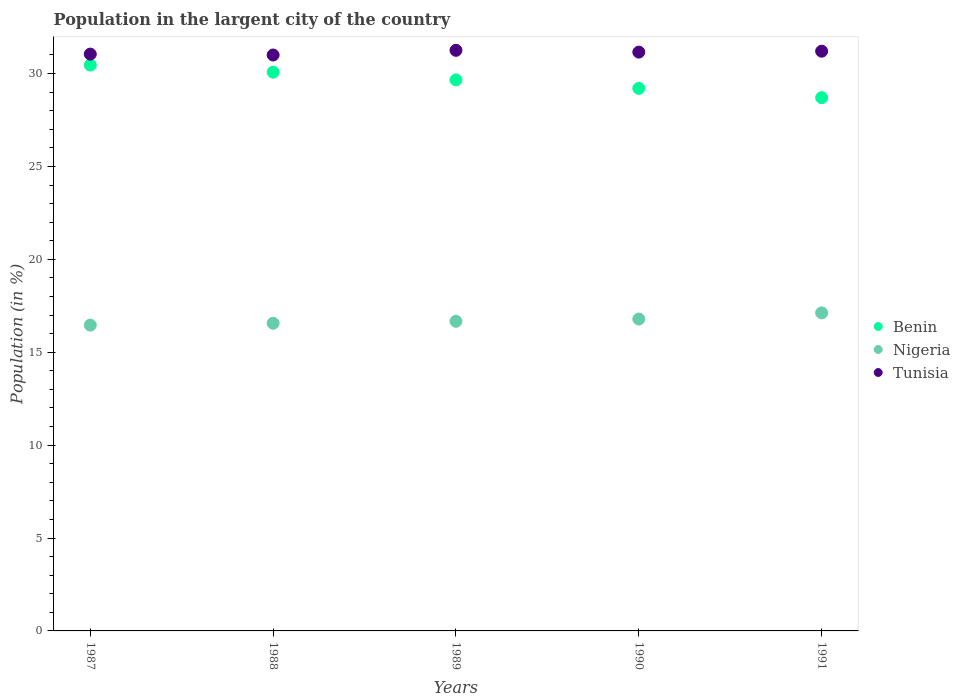How many different coloured dotlines are there?
Ensure brevity in your answer.  3. What is the percentage of population in the largent city in Tunisia in 1991?
Your answer should be very brief. 31.2. Across all years, what is the maximum percentage of population in the largent city in Benin?
Keep it short and to the point. 30.46. Across all years, what is the minimum percentage of population in the largent city in Tunisia?
Keep it short and to the point. 31. In which year was the percentage of population in the largent city in Tunisia minimum?
Your answer should be compact. 1988. What is the total percentage of population in the largent city in Tunisia in the graph?
Keep it short and to the point. 155.66. What is the difference between the percentage of population in the largent city in Nigeria in 1988 and that in 1989?
Provide a succinct answer. -0.11. What is the difference between the percentage of population in the largent city in Tunisia in 1991 and the percentage of population in the largent city in Benin in 1989?
Your response must be concise. 1.54. What is the average percentage of population in the largent city in Tunisia per year?
Your answer should be very brief. 31.13. In the year 1987, what is the difference between the percentage of population in the largent city in Nigeria and percentage of population in the largent city in Tunisia?
Give a very brief answer. -14.59. What is the ratio of the percentage of population in the largent city in Benin in 1989 to that in 1990?
Ensure brevity in your answer.  1.02. Is the percentage of population in the largent city in Tunisia in 1987 less than that in 1990?
Your answer should be compact. Yes. Is the difference between the percentage of population in the largent city in Nigeria in 1988 and 1991 greater than the difference between the percentage of population in the largent city in Tunisia in 1988 and 1991?
Your response must be concise. No. What is the difference between the highest and the second highest percentage of population in the largent city in Tunisia?
Your response must be concise. 0.05. What is the difference between the highest and the lowest percentage of population in the largent city in Nigeria?
Your answer should be compact. 0.66. In how many years, is the percentage of population in the largent city in Benin greater than the average percentage of population in the largent city in Benin taken over all years?
Your answer should be compact. 3. Is the sum of the percentage of population in the largent city in Nigeria in 1988 and 1990 greater than the maximum percentage of population in the largent city in Benin across all years?
Keep it short and to the point. Yes. Is it the case that in every year, the sum of the percentage of population in the largent city in Tunisia and percentage of population in the largent city in Nigeria  is greater than the percentage of population in the largent city in Benin?
Give a very brief answer. Yes. Is the percentage of population in the largent city in Benin strictly greater than the percentage of population in the largent city in Tunisia over the years?
Your response must be concise. No. How many years are there in the graph?
Make the answer very short. 5. What is the difference between two consecutive major ticks on the Y-axis?
Your response must be concise. 5. Does the graph contain any zero values?
Provide a short and direct response. No. Does the graph contain grids?
Your answer should be compact. No. Where does the legend appear in the graph?
Offer a very short reply. Center right. What is the title of the graph?
Your answer should be very brief. Population in the largent city of the country. Does "Israel" appear as one of the legend labels in the graph?
Keep it short and to the point. No. What is the label or title of the X-axis?
Make the answer very short. Years. What is the label or title of the Y-axis?
Offer a very short reply. Population (in %). What is the Population (in %) in Benin in 1987?
Offer a terse response. 30.46. What is the Population (in %) of Nigeria in 1987?
Offer a terse response. 16.46. What is the Population (in %) in Tunisia in 1987?
Your answer should be very brief. 31.05. What is the Population (in %) in Benin in 1988?
Offer a very short reply. 30.08. What is the Population (in %) in Nigeria in 1988?
Offer a very short reply. 16.56. What is the Population (in %) of Tunisia in 1988?
Ensure brevity in your answer.  31. What is the Population (in %) in Benin in 1989?
Provide a succinct answer. 29.66. What is the Population (in %) of Nigeria in 1989?
Offer a terse response. 16.67. What is the Population (in %) of Tunisia in 1989?
Make the answer very short. 31.25. What is the Population (in %) in Benin in 1990?
Your answer should be compact. 29.2. What is the Population (in %) of Nigeria in 1990?
Offer a very short reply. 16.79. What is the Population (in %) in Tunisia in 1990?
Offer a terse response. 31.15. What is the Population (in %) in Benin in 1991?
Ensure brevity in your answer.  28.7. What is the Population (in %) of Nigeria in 1991?
Your response must be concise. 17.12. What is the Population (in %) of Tunisia in 1991?
Ensure brevity in your answer.  31.2. Across all years, what is the maximum Population (in %) of Benin?
Offer a terse response. 30.46. Across all years, what is the maximum Population (in %) of Nigeria?
Offer a very short reply. 17.12. Across all years, what is the maximum Population (in %) of Tunisia?
Your response must be concise. 31.25. Across all years, what is the minimum Population (in %) in Benin?
Offer a terse response. 28.7. Across all years, what is the minimum Population (in %) of Nigeria?
Offer a very short reply. 16.46. Across all years, what is the minimum Population (in %) in Tunisia?
Ensure brevity in your answer.  31. What is the total Population (in %) of Benin in the graph?
Offer a terse response. 148.1. What is the total Population (in %) in Nigeria in the graph?
Make the answer very short. 83.59. What is the total Population (in %) in Tunisia in the graph?
Your answer should be very brief. 155.66. What is the difference between the Population (in %) in Benin in 1987 and that in 1988?
Offer a very short reply. 0.38. What is the difference between the Population (in %) in Nigeria in 1987 and that in 1988?
Offer a terse response. -0.1. What is the difference between the Population (in %) of Tunisia in 1987 and that in 1988?
Your answer should be compact. 0.05. What is the difference between the Population (in %) in Benin in 1987 and that in 1989?
Your answer should be very brief. 0.8. What is the difference between the Population (in %) in Nigeria in 1987 and that in 1989?
Provide a short and direct response. -0.21. What is the difference between the Population (in %) of Tunisia in 1987 and that in 1989?
Provide a succinct answer. -0.2. What is the difference between the Population (in %) of Benin in 1987 and that in 1990?
Provide a succinct answer. 1.26. What is the difference between the Population (in %) in Nigeria in 1987 and that in 1990?
Offer a terse response. -0.33. What is the difference between the Population (in %) in Tunisia in 1987 and that in 1990?
Your response must be concise. -0.11. What is the difference between the Population (in %) of Benin in 1987 and that in 1991?
Your answer should be compact. 1.76. What is the difference between the Population (in %) in Nigeria in 1987 and that in 1991?
Offer a terse response. -0.66. What is the difference between the Population (in %) of Tunisia in 1987 and that in 1991?
Offer a very short reply. -0.16. What is the difference between the Population (in %) of Benin in 1988 and that in 1989?
Offer a very short reply. 0.42. What is the difference between the Population (in %) in Nigeria in 1988 and that in 1989?
Provide a short and direct response. -0.11. What is the difference between the Population (in %) in Tunisia in 1988 and that in 1989?
Your answer should be compact. -0.25. What is the difference between the Population (in %) in Benin in 1988 and that in 1990?
Offer a very short reply. 0.87. What is the difference between the Population (in %) in Nigeria in 1988 and that in 1990?
Make the answer very short. -0.23. What is the difference between the Population (in %) in Tunisia in 1988 and that in 1990?
Ensure brevity in your answer.  -0.16. What is the difference between the Population (in %) in Benin in 1988 and that in 1991?
Offer a very short reply. 1.37. What is the difference between the Population (in %) in Nigeria in 1988 and that in 1991?
Your answer should be compact. -0.56. What is the difference between the Population (in %) of Tunisia in 1988 and that in 1991?
Your answer should be compact. -0.21. What is the difference between the Population (in %) in Benin in 1989 and that in 1990?
Keep it short and to the point. 0.46. What is the difference between the Population (in %) of Nigeria in 1989 and that in 1990?
Offer a terse response. -0.12. What is the difference between the Population (in %) of Tunisia in 1989 and that in 1990?
Provide a succinct answer. 0.1. What is the difference between the Population (in %) in Benin in 1989 and that in 1991?
Make the answer very short. 0.96. What is the difference between the Population (in %) of Nigeria in 1989 and that in 1991?
Keep it short and to the point. -0.45. What is the difference between the Population (in %) of Tunisia in 1989 and that in 1991?
Your response must be concise. 0.05. What is the difference between the Population (in %) in Benin in 1990 and that in 1991?
Keep it short and to the point. 0.5. What is the difference between the Population (in %) in Nigeria in 1990 and that in 1991?
Offer a terse response. -0.33. What is the difference between the Population (in %) of Tunisia in 1990 and that in 1991?
Provide a short and direct response. -0.05. What is the difference between the Population (in %) in Benin in 1987 and the Population (in %) in Nigeria in 1988?
Your response must be concise. 13.9. What is the difference between the Population (in %) of Benin in 1987 and the Population (in %) of Tunisia in 1988?
Provide a short and direct response. -0.54. What is the difference between the Population (in %) in Nigeria in 1987 and the Population (in %) in Tunisia in 1988?
Offer a very short reply. -14.54. What is the difference between the Population (in %) in Benin in 1987 and the Population (in %) in Nigeria in 1989?
Make the answer very short. 13.79. What is the difference between the Population (in %) of Benin in 1987 and the Population (in %) of Tunisia in 1989?
Make the answer very short. -0.79. What is the difference between the Population (in %) in Nigeria in 1987 and the Population (in %) in Tunisia in 1989?
Provide a short and direct response. -14.79. What is the difference between the Population (in %) of Benin in 1987 and the Population (in %) of Nigeria in 1990?
Give a very brief answer. 13.67. What is the difference between the Population (in %) in Benin in 1987 and the Population (in %) in Tunisia in 1990?
Your response must be concise. -0.7. What is the difference between the Population (in %) of Nigeria in 1987 and the Population (in %) of Tunisia in 1990?
Your answer should be compact. -14.69. What is the difference between the Population (in %) in Benin in 1987 and the Population (in %) in Nigeria in 1991?
Your answer should be very brief. 13.34. What is the difference between the Population (in %) in Benin in 1987 and the Population (in %) in Tunisia in 1991?
Give a very brief answer. -0.75. What is the difference between the Population (in %) of Nigeria in 1987 and the Population (in %) of Tunisia in 1991?
Provide a succinct answer. -14.74. What is the difference between the Population (in %) of Benin in 1988 and the Population (in %) of Nigeria in 1989?
Offer a terse response. 13.41. What is the difference between the Population (in %) in Benin in 1988 and the Population (in %) in Tunisia in 1989?
Make the answer very short. -1.18. What is the difference between the Population (in %) of Nigeria in 1988 and the Population (in %) of Tunisia in 1989?
Offer a terse response. -14.69. What is the difference between the Population (in %) of Benin in 1988 and the Population (in %) of Nigeria in 1990?
Offer a very short reply. 13.29. What is the difference between the Population (in %) of Benin in 1988 and the Population (in %) of Tunisia in 1990?
Give a very brief answer. -1.08. What is the difference between the Population (in %) of Nigeria in 1988 and the Population (in %) of Tunisia in 1990?
Provide a succinct answer. -14.59. What is the difference between the Population (in %) in Benin in 1988 and the Population (in %) in Nigeria in 1991?
Your answer should be compact. 12.96. What is the difference between the Population (in %) in Benin in 1988 and the Population (in %) in Tunisia in 1991?
Give a very brief answer. -1.13. What is the difference between the Population (in %) in Nigeria in 1988 and the Population (in %) in Tunisia in 1991?
Give a very brief answer. -14.64. What is the difference between the Population (in %) of Benin in 1989 and the Population (in %) of Nigeria in 1990?
Keep it short and to the point. 12.87. What is the difference between the Population (in %) of Benin in 1989 and the Population (in %) of Tunisia in 1990?
Your response must be concise. -1.5. What is the difference between the Population (in %) of Nigeria in 1989 and the Population (in %) of Tunisia in 1990?
Offer a very short reply. -14.49. What is the difference between the Population (in %) in Benin in 1989 and the Population (in %) in Nigeria in 1991?
Provide a short and direct response. 12.54. What is the difference between the Population (in %) in Benin in 1989 and the Population (in %) in Tunisia in 1991?
Provide a succinct answer. -1.54. What is the difference between the Population (in %) of Nigeria in 1989 and the Population (in %) of Tunisia in 1991?
Provide a succinct answer. -14.54. What is the difference between the Population (in %) of Benin in 1990 and the Population (in %) of Nigeria in 1991?
Provide a short and direct response. 12.08. What is the difference between the Population (in %) in Benin in 1990 and the Population (in %) in Tunisia in 1991?
Give a very brief answer. -2. What is the difference between the Population (in %) of Nigeria in 1990 and the Population (in %) of Tunisia in 1991?
Your answer should be compact. -14.42. What is the average Population (in %) of Benin per year?
Make the answer very short. 29.62. What is the average Population (in %) in Nigeria per year?
Give a very brief answer. 16.72. What is the average Population (in %) of Tunisia per year?
Offer a very short reply. 31.13. In the year 1987, what is the difference between the Population (in %) of Benin and Population (in %) of Nigeria?
Ensure brevity in your answer.  14. In the year 1987, what is the difference between the Population (in %) of Benin and Population (in %) of Tunisia?
Provide a short and direct response. -0.59. In the year 1987, what is the difference between the Population (in %) in Nigeria and Population (in %) in Tunisia?
Provide a succinct answer. -14.59. In the year 1988, what is the difference between the Population (in %) in Benin and Population (in %) in Nigeria?
Offer a terse response. 13.52. In the year 1988, what is the difference between the Population (in %) of Benin and Population (in %) of Tunisia?
Your answer should be very brief. -0.92. In the year 1988, what is the difference between the Population (in %) in Nigeria and Population (in %) in Tunisia?
Offer a very short reply. -14.44. In the year 1989, what is the difference between the Population (in %) in Benin and Population (in %) in Nigeria?
Make the answer very short. 12.99. In the year 1989, what is the difference between the Population (in %) in Benin and Population (in %) in Tunisia?
Make the answer very short. -1.59. In the year 1989, what is the difference between the Population (in %) of Nigeria and Population (in %) of Tunisia?
Provide a short and direct response. -14.58. In the year 1990, what is the difference between the Population (in %) of Benin and Population (in %) of Nigeria?
Make the answer very short. 12.42. In the year 1990, what is the difference between the Population (in %) in Benin and Population (in %) in Tunisia?
Your answer should be compact. -1.95. In the year 1990, what is the difference between the Population (in %) in Nigeria and Population (in %) in Tunisia?
Ensure brevity in your answer.  -14.37. In the year 1991, what is the difference between the Population (in %) in Benin and Population (in %) in Nigeria?
Provide a short and direct response. 11.58. In the year 1991, what is the difference between the Population (in %) of Benin and Population (in %) of Tunisia?
Your answer should be very brief. -2.5. In the year 1991, what is the difference between the Population (in %) of Nigeria and Population (in %) of Tunisia?
Your response must be concise. -14.08. What is the ratio of the Population (in %) in Benin in 1987 to that in 1988?
Provide a succinct answer. 1.01. What is the ratio of the Population (in %) in Tunisia in 1987 to that in 1988?
Offer a very short reply. 1. What is the ratio of the Population (in %) of Benin in 1987 to that in 1989?
Provide a short and direct response. 1.03. What is the ratio of the Population (in %) of Nigeria in 1987 to that in 1989?
Offer a terse response. 0.99. What is the ratio of the Population (in %) in Benin in 1987 to that in 1990?
Your response must be concise. 1.04. What is the ratio of the Population (in %) in Nigeria in 1987 to that in 1990?
Keep it short and to the point. 0.98. What is the ratio of the Population (in %) of Benin in 1987 to that in 1991?
Your answer should be compact. 1.06. What is the ratio of the Population (in %) in Nigeria in 1987 to that in 1991?
Your answer should be compact. 0.96. What is the ratio of the Population (in %) in Benin in 1988 to that in 1989?
Provide a short and direct response. 1.01. What is the ratio of the Population (in %) in Tunisia in 1988 to that in 1989?
Ensure brevity in your answer.  0.99. What is the ratio of the Population (in %) of Benin in 1988 to that in 1990?
Your answer should be very brief. 1.03. What is the ratio of the Population (in %) of Nigeria in 1988 to that in 1990?
Make the answer very short. 0.99. What is the ratio of the Population (in %) in Benin in 1988 to that in 1991?
Keep it short and to the point. 1.05. What is the ratio of the Population (in %) of Nigeria in 1988 to that in 1991?
Make the answer very short. 0.97. What is the ratio of the Population (in %) in Benin in 1989 to that in 1990?
Ensure brevity in your answer.  1.02. What is the ratio of the Population (in %) in Tunisia in 1989 to that in 1990?
Your response must be concise. 1. What is the ratio of the Population (in %) in Benin in 1989 to that in 1991?
Your answer should be very brief. 1.03. What is the ratio of the Population (in %) in Nigeria in 1989 to that in 1991?
Give a very brief answer. 0.97. What is the ratio of the Population (in %) in Tunisia in 1989 to that in 1991?
Make the answer very short. 1. What is the ratio of the Population (in %) of Benin in 1990 to that in 1991?
Ensure brevity in your answer.  1.02. What is the ratio of the Population (in %) in Nigeria in 1990 to that in 1991?
Make the answer very short. 0.98. What is the difference between the highest and the second highest Population (in %) in Benin?
Give a very brief answer. 0.38. What is the difference between the highest and the second highest Population (in %) in Nigeria?
Give a very brief answer. 0.33. What is the difference between the highest and the second highest Population (in %) of Tunisia?
Your response must be concise. 0.05. What is the difference between the highest and the lowest Population (in %) in Benin?
Your response must be concise. 1.76. What is the difference between the highest and the lowest Population (in %) of Nigeria?
Provide a short and direct response. 0.66. What is the difference between the highest and the lowest Population (in %) in Tunisia?
Your response must be concise. 0.25. 